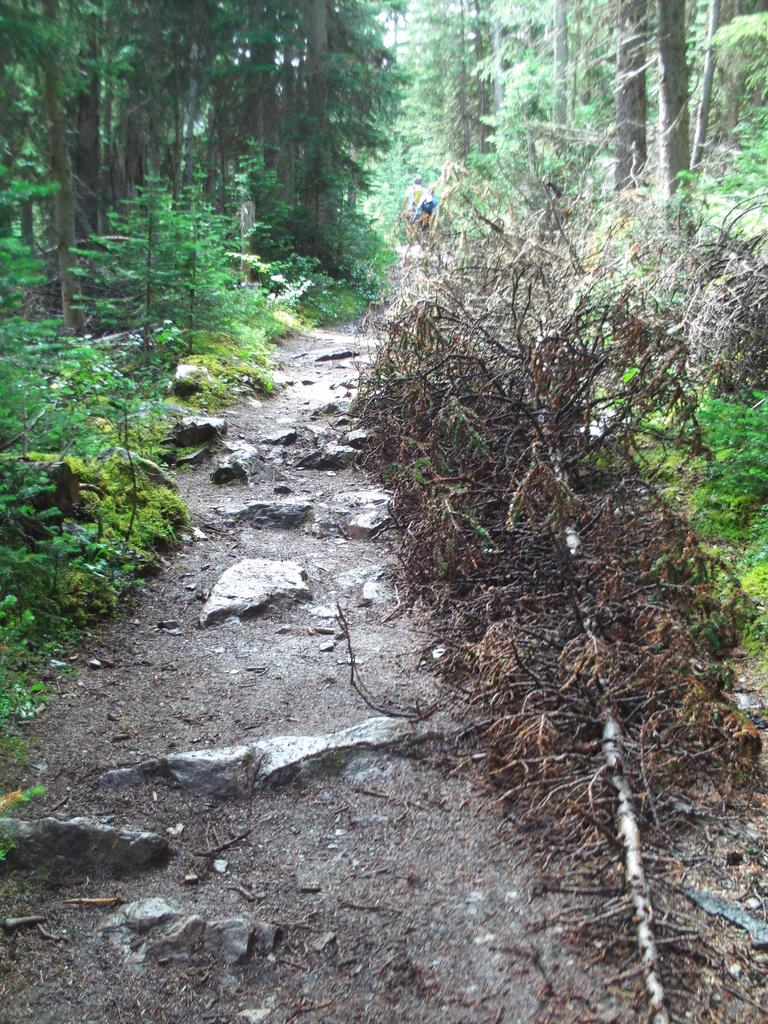What type of natural elements can be seen on the pathway in the image? There are rocks on the pathway in the image. What other natural elements are present in the image? There are plants and trees in the image. What type of potato is being grown in the image? There is no potato present in the image; it features rocks, plants, and trees. 